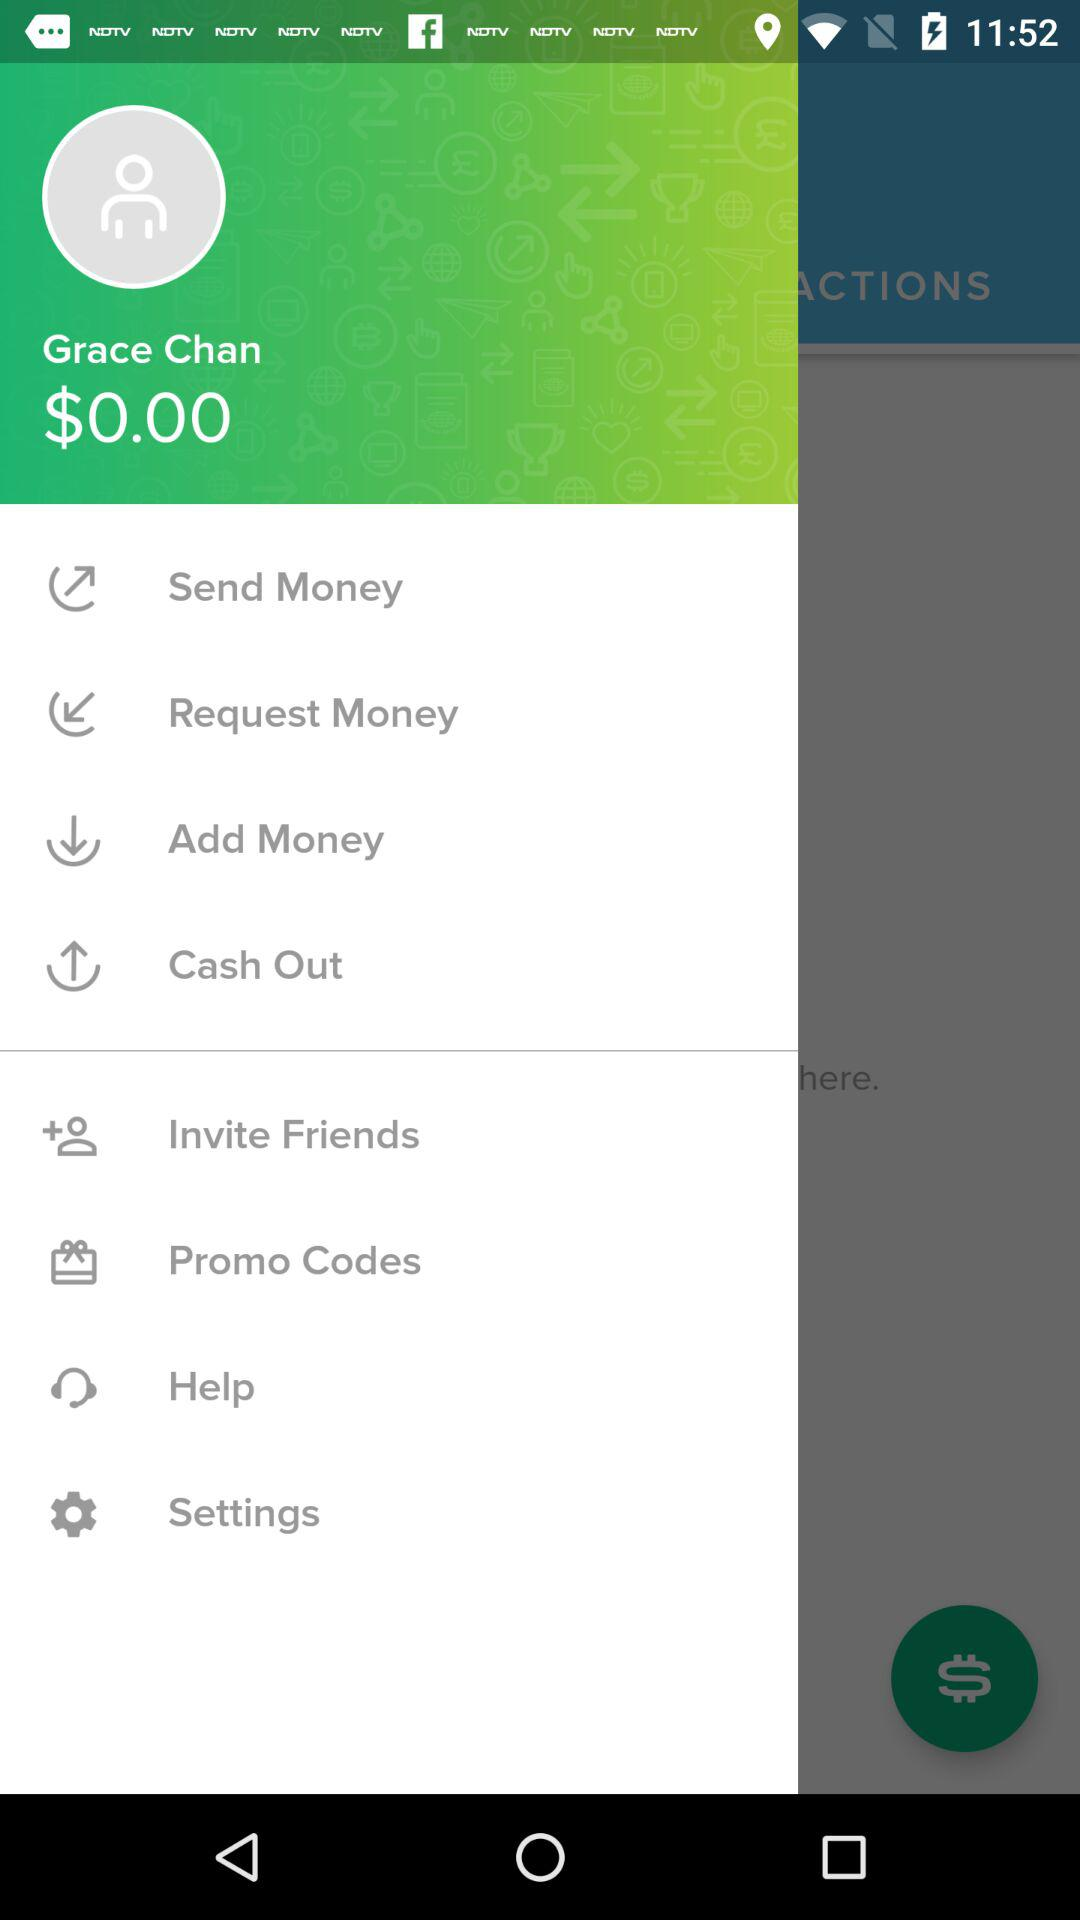How much money do I have in my account?
Answer the question using a single word or phrase. $0.00 